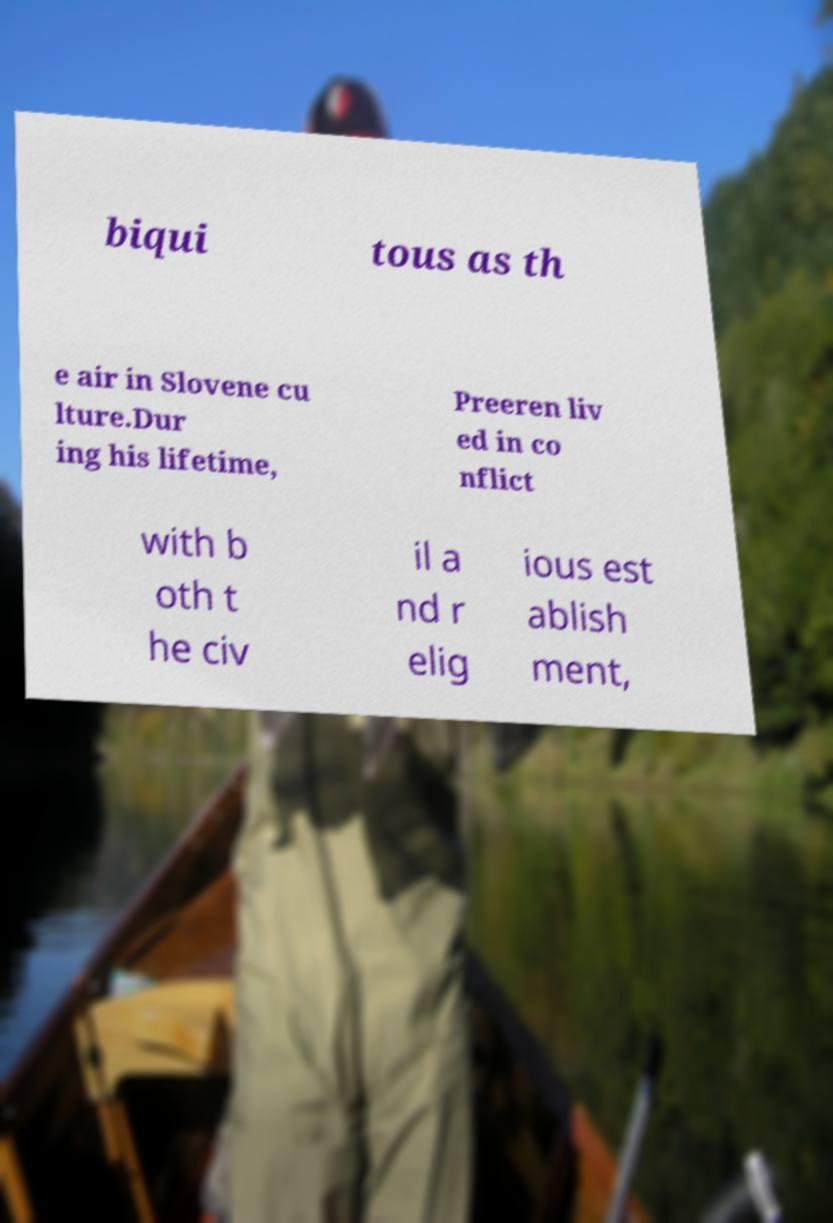For documentation purposes, I need the text within this image transcribed. Could you provide that? biqui tous as th e air in Slovene cu lture.Dur ing his lifetime, Preeren liv ed in co nflict with b oth t he civ il a nd r elig ious est ablish ment, 